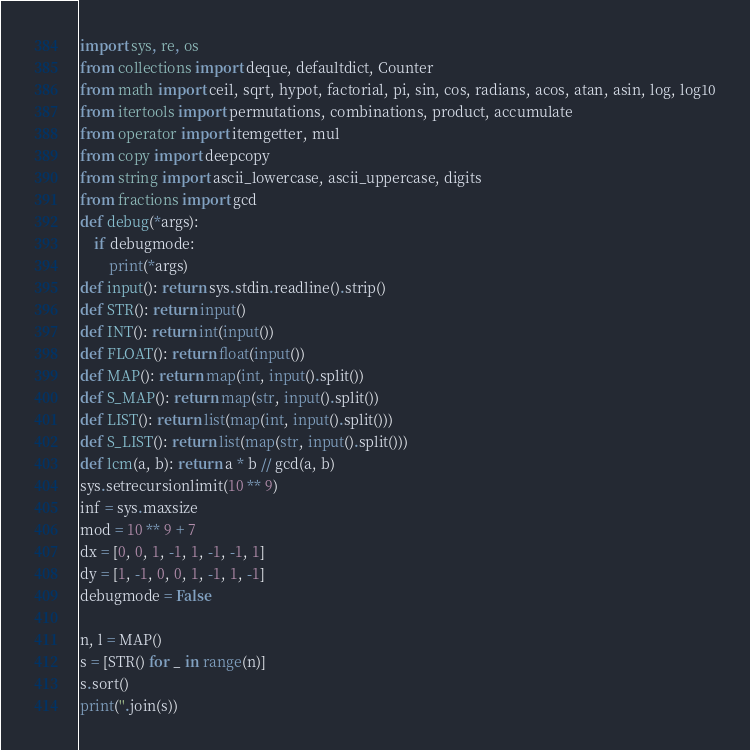Convert code to text. <code><loc_0><loc_0><loc_500><loc_500><_Python_>import sys, re, os
from collections import deque, defaultdict, Counter
from math import ceil, sqrt, hypot, factorial, pi, sin, cos, radians, acos, atan, asin, log, log10
from itertools import permutations, combinations, product, accumulate
from operator import itemgetter, mul
from copy import deepcopy
from string import ascii_lowercase, ascii_uppercase, digits
from fractions import gcd
def debug(*args):
    if debugmode:
        print(*args)
def input(): return sys.stdin.readline().strip()
def STR(): return input()
def INT(): return int(input())
def FLOAT(): return float(input())
def MAP(): return map(int, input().split())
def S_MAP(): return map(str, input().split())
def LIST(): return list(map(int, input().split()))
def S_LIST(): return list(map(str, input().split()))
def lcm(a, b): return a * b // gcd(a, b)
sys.setrecursionlimit(10 ** 9)
inf = sys.maxsize
mod = 10 ** 9 + 7
dx = [0, 0, 1, -1, 1, -1, -1, 1]
dy = [1, -1, 0, 0, 1, -1, 1, -1]
debugmode = False

n, l = MAP()
s = [STR() for _ in range(n)]
s.sort()
print(''.join(s))</code> 